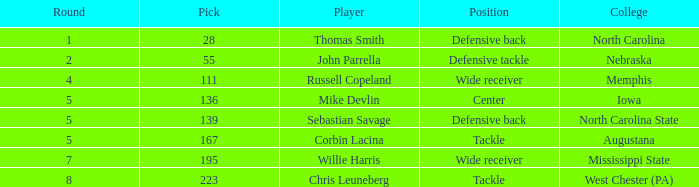What is the overall sum of a round consisting of a 55 pick? 2.0. 